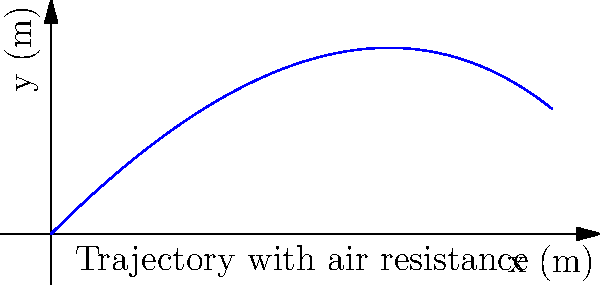As a visual effects supervisor, you're working on a scene involving a projectile launch. The projectile is fired with an initial velocity of 50 m/s at a 45-degree angle. Considering air resistance proportional to velocity with a drag coefficient of 0.1 kg/s, what is the maximum height reached by the projectile? Express your answer in meters, rounded to one decimal place. To solve this problem, we'll follow these steps:

1) The equations of motion for a projectile with air resistance are:

   $$\frac{dx}{dt} = v_0 \cos(\theta) e^{-kt}$$
   $$\frac{dy}{dt} = v_0 \sin(\theta) e^{-kt} - \frac{g}{k}(1-e^{-kt})$$

   Where $k$ is the drag coefficient divided by mass.

2) Integrating these equations gives us:

   $$x(t) = \frac{v_0 \cos(\theta)}{k}(1-e^{-kt})$$
   $$y(t) = \frac{v_0 \sin(\theta)+g/k}{k}(1-e^{-kt})-\frac{g}{k}t$$

3) The maximum height is reached when $\frac{dy}{dt} = 0$. This occurs at time $t_{max}$:

   $$t_{max} = \frac{1}{k}\ln(\frac{v_0 k \sin(\theta)}{g}+1)$$

4) Substituting the given values:
   $v_0 = 50$ m/s, $\theta = 45°$, $k = 0.1$ kg/s, $g = 9.8$ m/s²

   $$t_{max} = \frac{1}{0.1}\ln(\frac{50 \cdot 0.1 \cdot \sin(45°)}{9.8}+1) \approx 3.56s$$

5) Now we can find the maximum height by substituting $t_{max}$ into the equation for $y(t)$:

   $$y_{max} = \frac{50 \sin(45°)+9.8/0.1}{0.1}(1-e^{-0.1 \cdot 3.56})-\frac{9.8}{0.1} \cdot 3.56$$

6) Calculating this gives us approximately 44.7 meters.
Answer: 44.7 m 